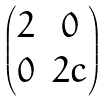<formula> <loc_0><loc_0><loc_500><loc_500>\begin{pmatrix} 2 & 0 \\ 0 & 2 c \end{pmatrix}</formula> 